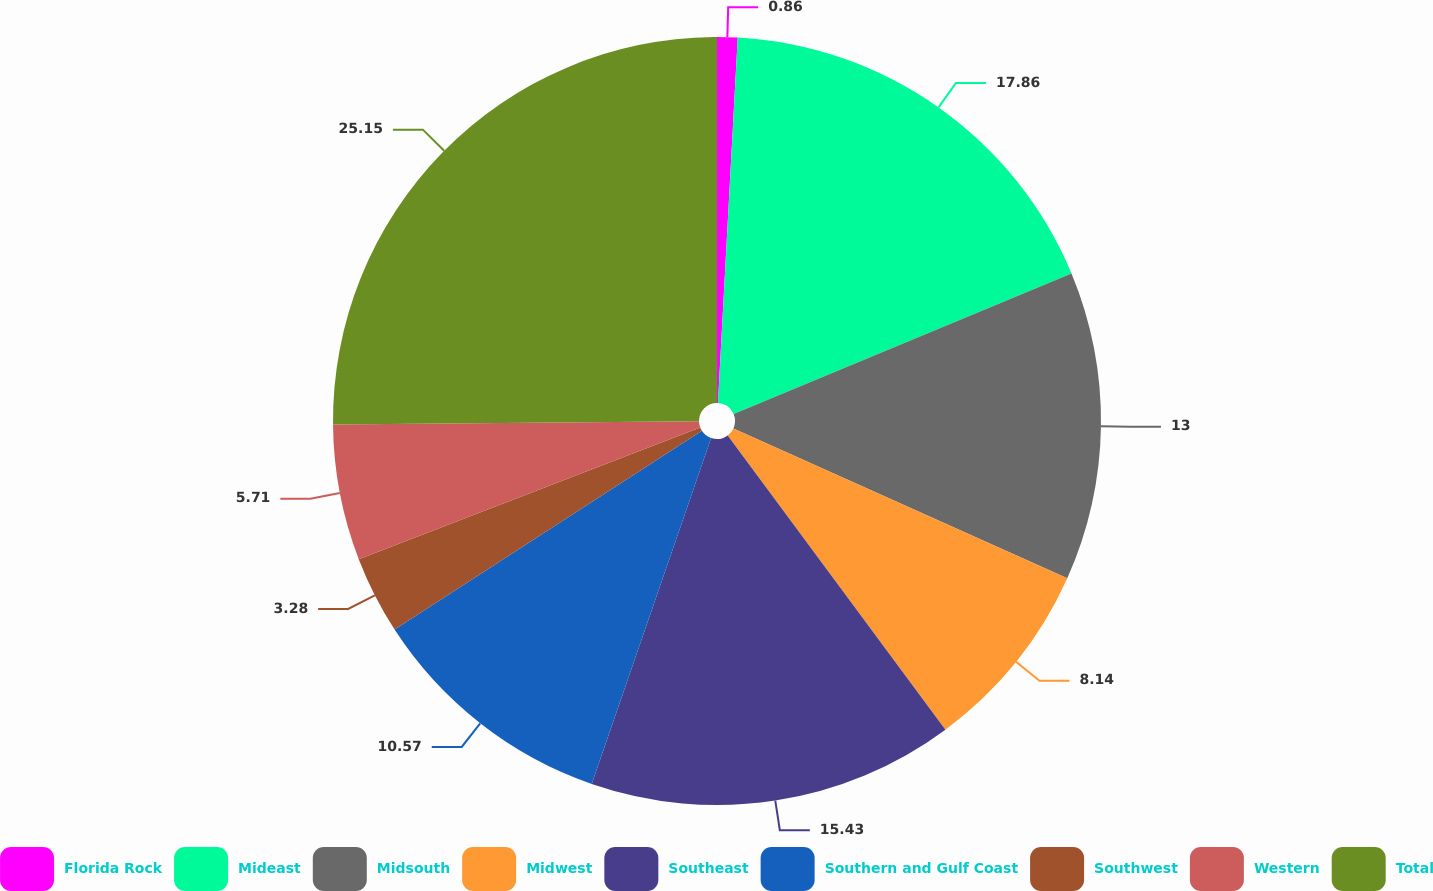<chart> <loc_0><loc_0><loc_500><loc_500><pie_chart><fcel>Florida Rock<fcel>Mideast<fcel>Midsouth<fcel>Midwest<fcel>Southeast<fcel>Southern and Gulf Coast<fcel>Southwest<fcel>Western<fcel>Total<nl><fcel>0.86%<fcel>17.86%<fcel>13.0%<fcel>8.14%<fcel>15.43%<fcel>10.57%<fcel>3.28%<fcel>5.71%<fcel>25.15%<nl></chart> 